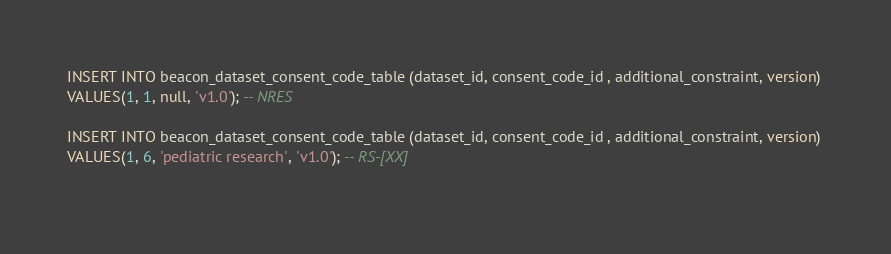Convert code to text. <code><loc_0><loc_0><loc_500><loc_500><_SQL_>INSERT INTO beacon_dataset_consent_code_table (dataset_id, consent_code_id , additional_constraint, version) 
VALUES(1, 1, null, 'v1.0'); -- NRES
 
INSERT INTO beacon_dataset_consent_code_table (dataset_id, consent_code_id , additional_constraint, version) 
VALUES(1, 6, 'pediatric research', 'v1.0'); -- RS-[XX]
 </code> 